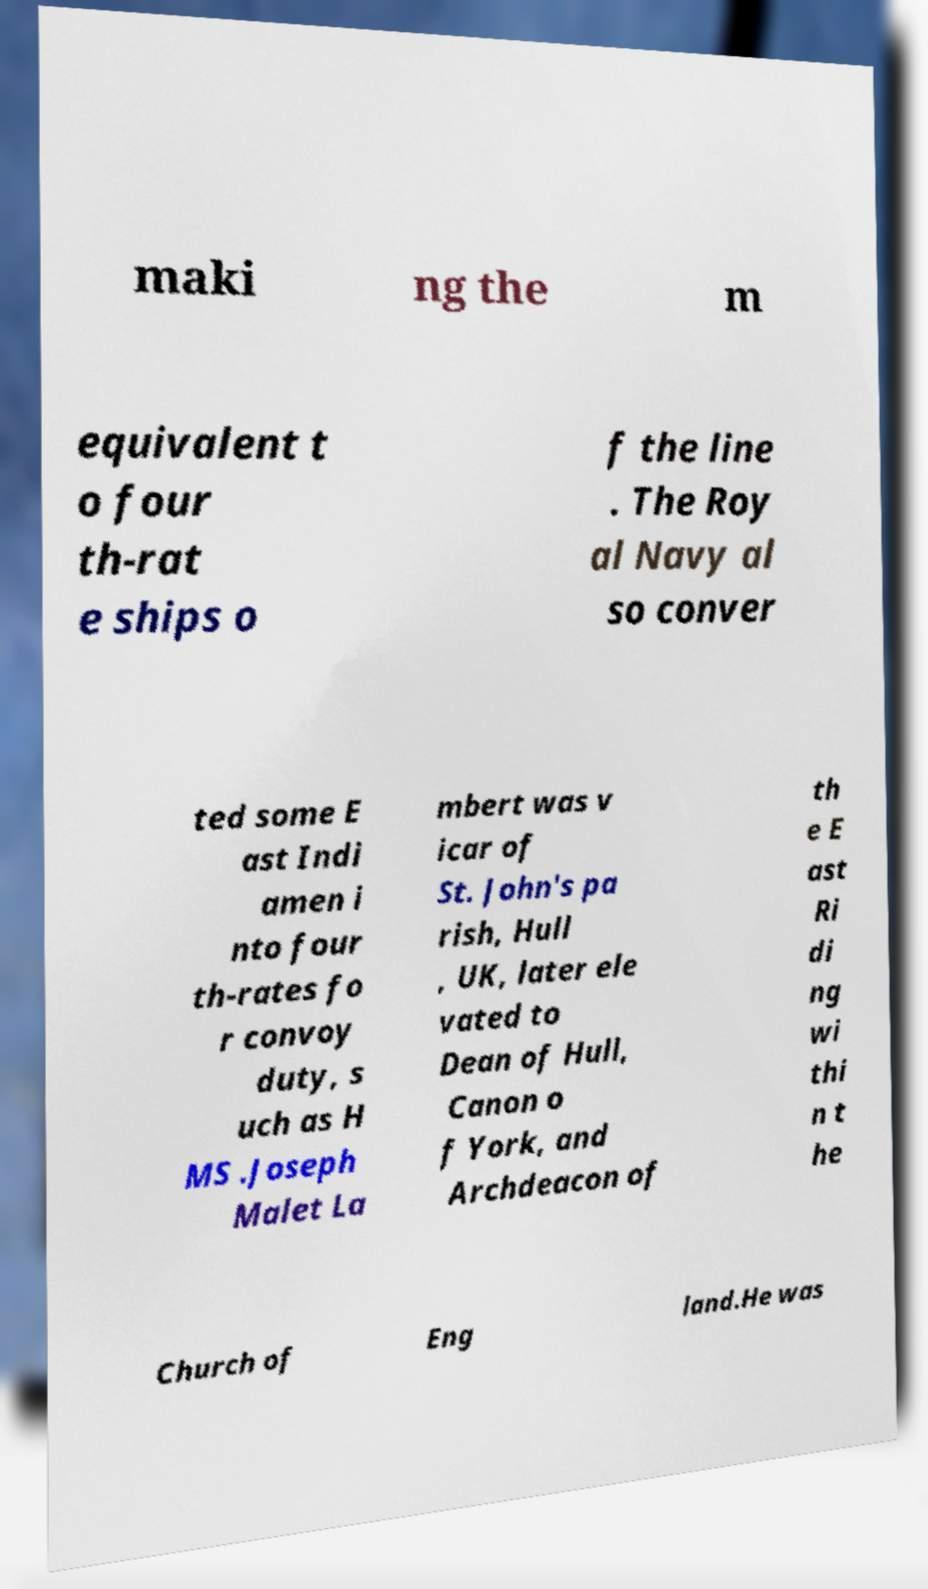What messages or text are displayed in this image? I need them in a readable, typed format. maki ng the m equivalent t o four th-rat e ships o f the line . The Roy al Navy al so conver ted some E ast Indi amen i nto four th-rates fo r convoy duty, s uch as H MS .Joseph Malet La mbert was v icar of St. John's pa rish, Hull , UK, later ele vated to Dean of Hull, Canon o f York, and Archdeacon of th e E ast Ri di ng wi thi n t he Church of Eng land.He was 